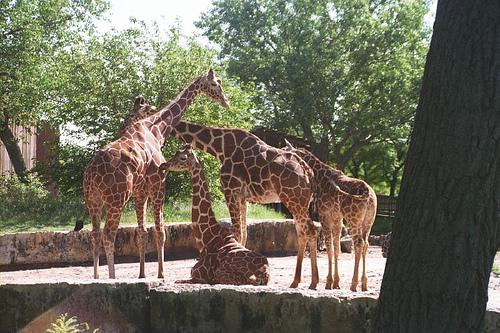Question: who is in the pen?
Choices:
A. Pigs.
B. Cow.
C. No one.
D. Babies.
Answer with the letter. Answer: C Question: what plant is behind them?
Choices:
A. Rose.
B. Trees.
C. Lily.
D. Sunflower.
Answer with the letter. Answer: B Question: what animal is this?
Choices:
A. Giraffe.
B. Horse.
C. Tiger.
D. Dog.
Answer with the letter. Answer: A Question: what color are the animals?
Choices:
A. Gray.
B. Calico.
C. Black.
D. Brown and white.
Answer with the letter. Answer: D Question: how many are standing?
Choices:
A. All but two.
B. Thirty.
C. Ten.
D. Three.
Answer with the letter. Answer: D 